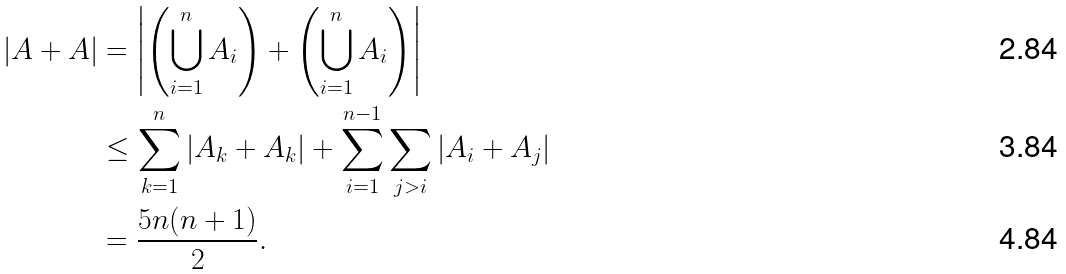<formula> <loc_0><loc_0><loc_500><loc_500>| A + A | & = \left | \left ( \bigcup _ { i = 1 } ^ { n } A _ { i } \right ) + \left ( \bigcup _ { i = 1 } ^ { n } A _ { i } \right ) \right | \\ & \leq \sum _ { k = 1 } ^ { n } | A _ { k } + A _ { k } | + \sum _ { i = 1 } ^ { n - 1 } \sum _ { j > i } | A _ { i } + A _ { j } | \\ & = \frac { 5 n ( n + 1 ) } { 2 } .</formula> 